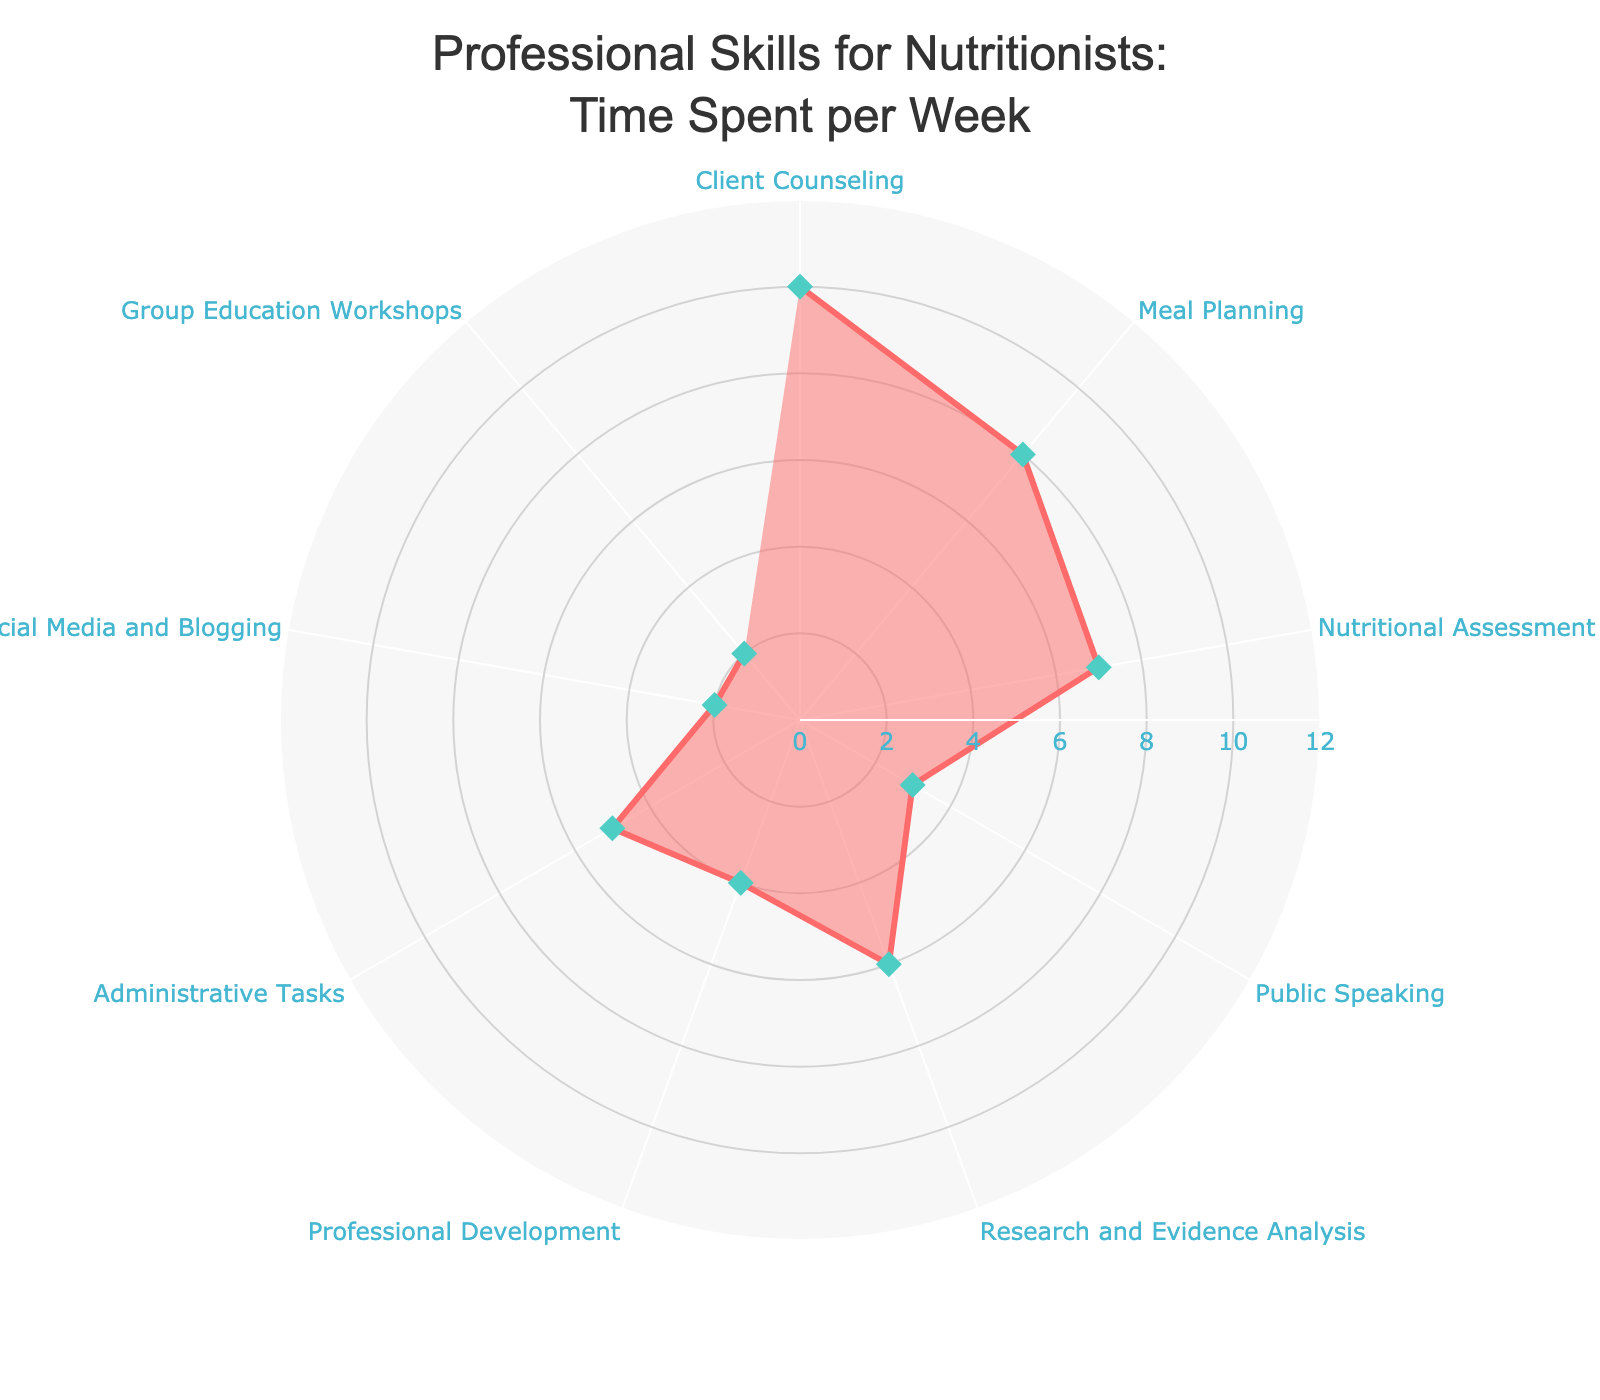Which skill has the highest time spent per week? To find the skill with the highest time spent, look at the value that reaches the furthest from the center of the radar chart.
Answer: Client Counseling Which three skills have the least time spent per week? Identify the three shortest distances from the center of the radar chart to determine the skills with the least hours spent.
Answer: Social Media and Blogging, Group Education Workshops, Public Speaking What is the total time spent on Meal Planning and Nutritional Assessment per week? To find the total time spent, add the hours for Meal Planning (8 hours) and Nutritional Assessment (7 hours): 8 + 7 = 15.
Answer: 15 hours How many hours per week are spent on Client Counseling compared to Social Media and Blogging combined? The time spent on Client Counseling is 10 hours. The time for Social Media and Blogging is 2 hours. The difference is 10 - 2 = 8 hours.
Answer: 8 hours Which skills have exactly 5 hours or less spent per week? Identify the skills where the data points are 5 or less in the radar chart.
Answer: Public Speaking, Professional Development, Administrative Tasks, Social Media and Blogging, Group Education Workshops What is the average time spent per week on Research and Evidence Analysis, Professional Development, and Social Media and Blogging? Add the hours for these three skills and divide by 3: (6 + 4 + 2) / 3 = 4.
Answer: 4 hours Is Public Speaking less time-consuming than Professional Development? Compare the hours for Public Speaking (3) with those for Professional Development (4).
Answer: Yes What is the combined time spent on Administrative Tasks and Group Education Workshops per week? Add the hours for Administrative Tasks (5) and Group Education Workshops (2): 5 + 2 = 7.
Answer: 7 hours Which two skills have a combined time spent closest to that of Client Counseling? Review the hours of each skill and identify pairs of skills whose combined hours are closest to 10 (Client Counseling). Meal Planning (8) + Social Media and Blogging (2) = 10.
Answer: Meal Planning and Social Media and Blogging How much more time is spent on Meal Planning compared to Public Speaking? Subtract the time spent on Public Speaking (3 hours) from the time spent on Meal Planning (8 hours): 8 - 3 = 5.
Answer: 5 hours 